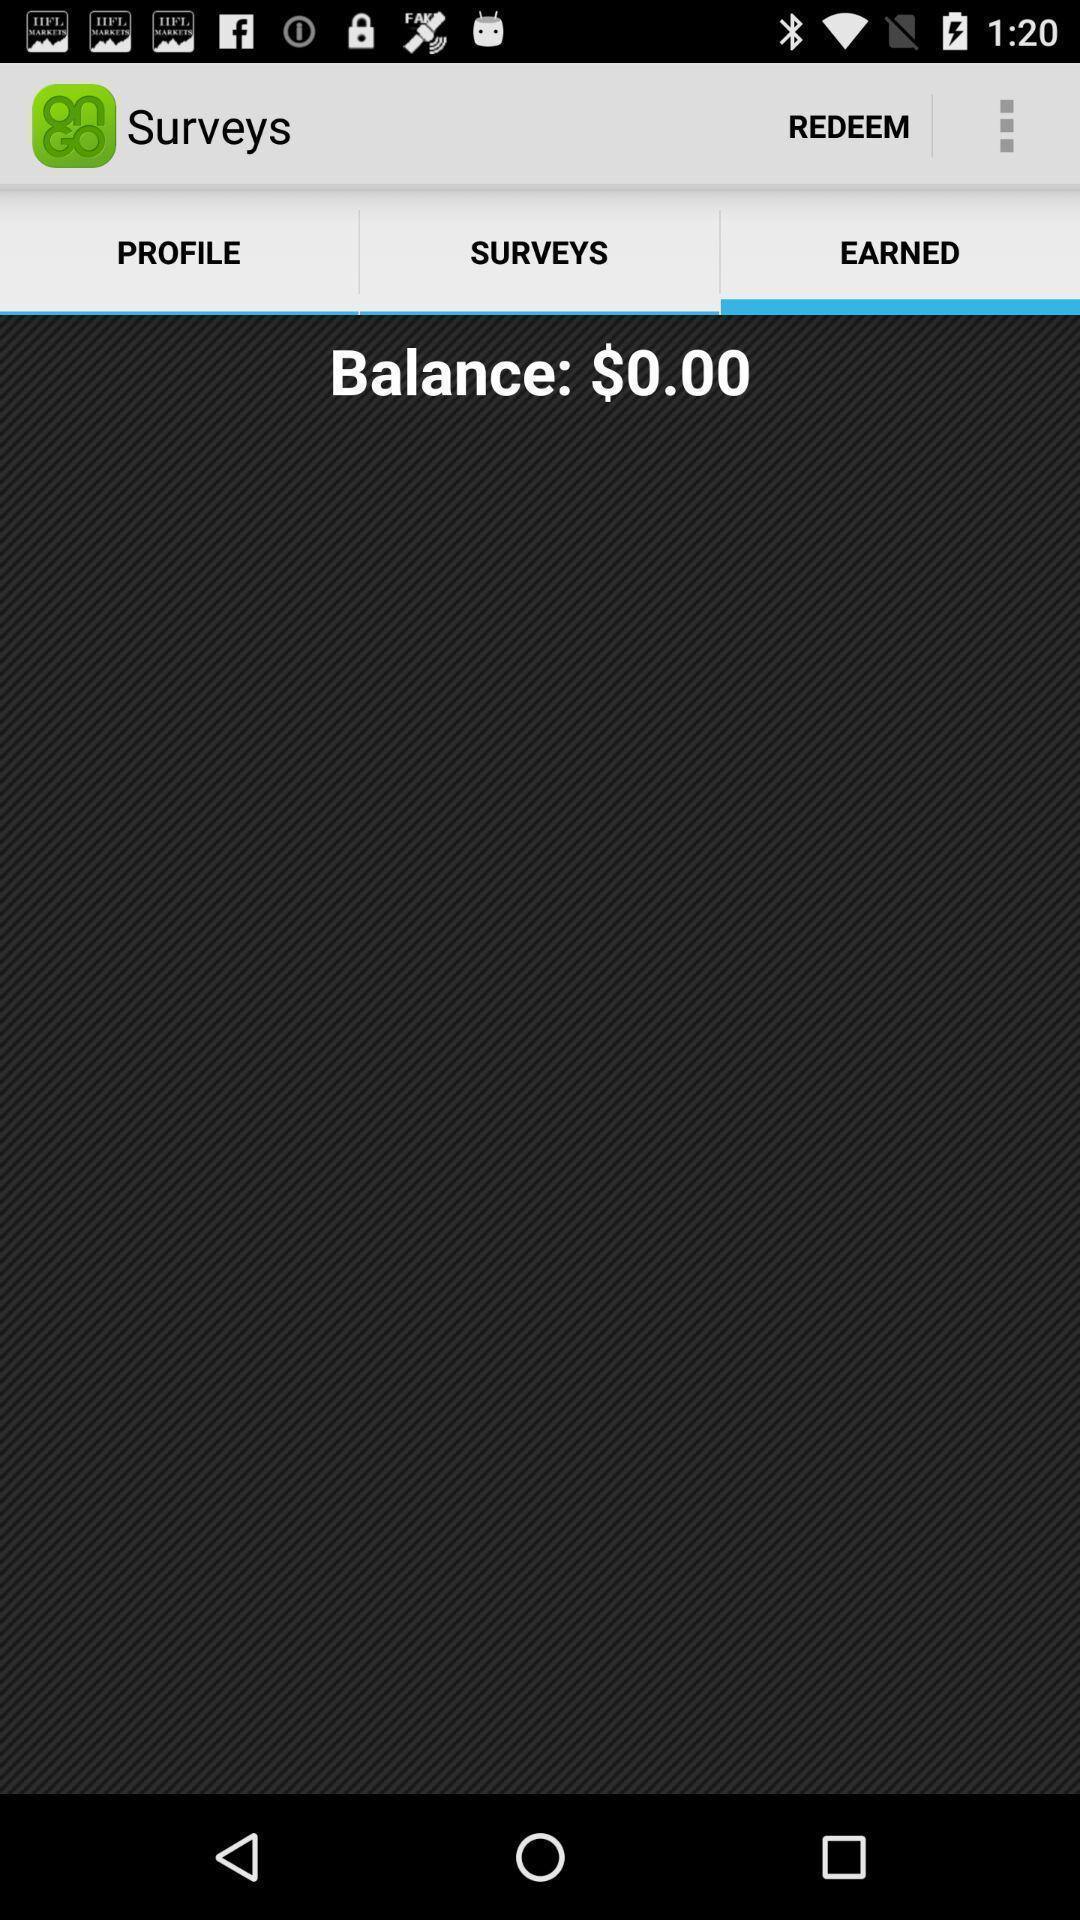Describe the content in this image. Screen showing earned money page. 